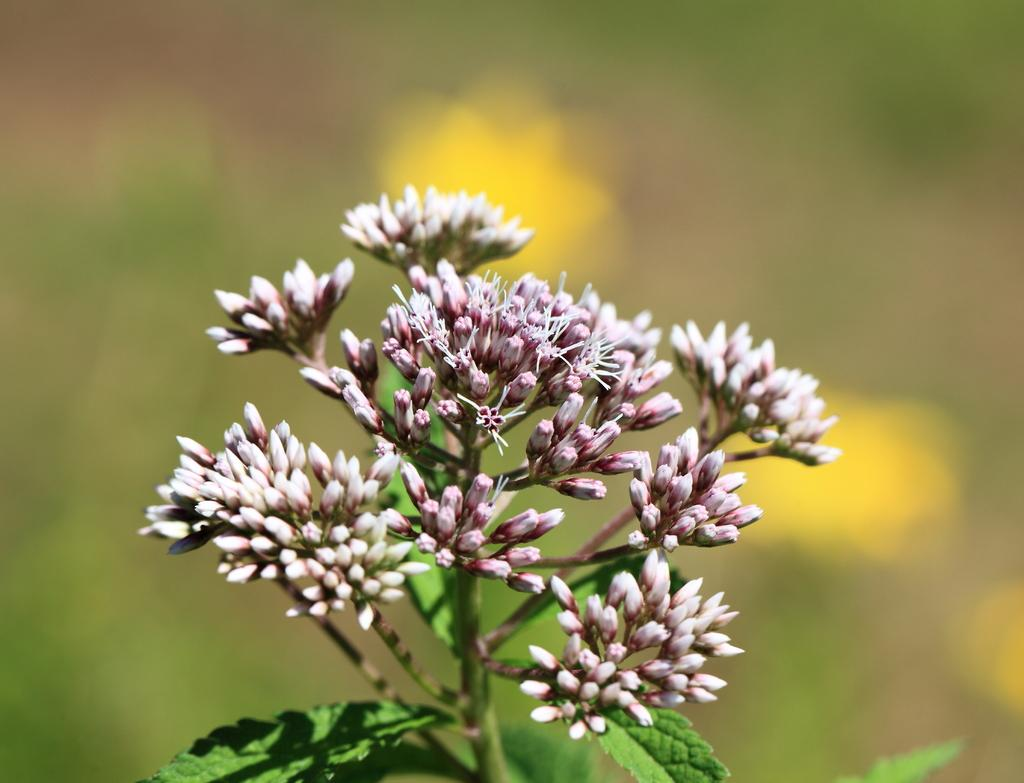What is the main subject in the center of the image? There are flowers in the center of the image. Are the flowers part of a larger plant? Yes, the flowers are part of a plant. Can you describe the background of the image? The background of the image is blurry. What type of waste can be seen on the seashore in the image? There is no seashore or waste present in the image; it features flowers in the center of the frame. 